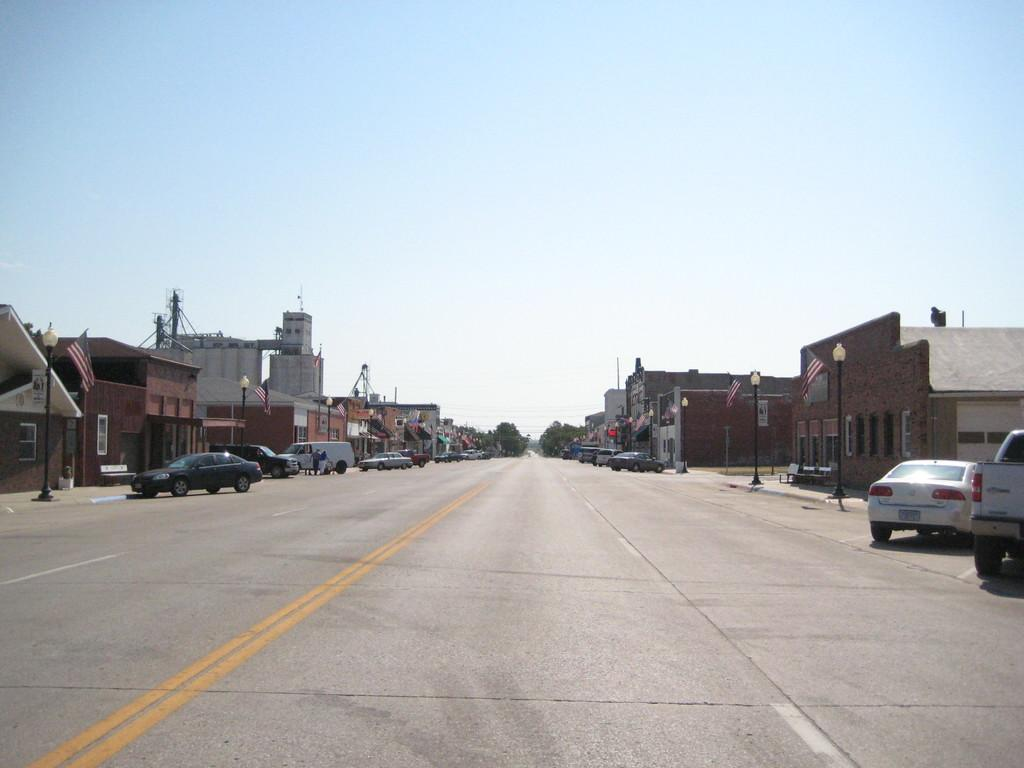What is the main feature of the image? There is a road in the image. What can be seen on the sides of the road? Vehicles, buildings, light poles, and flags are present on the sides of the road. Can you describe the buildings in the image? The buildings have windows. What is visible in the background of the image? The sky is visible in the background of the image. Where is the toy store located in the image? There is no toy store mentioned or visible in the image. Can you tell me how many bridges are present in the image? There are no bridges visible in the image. 